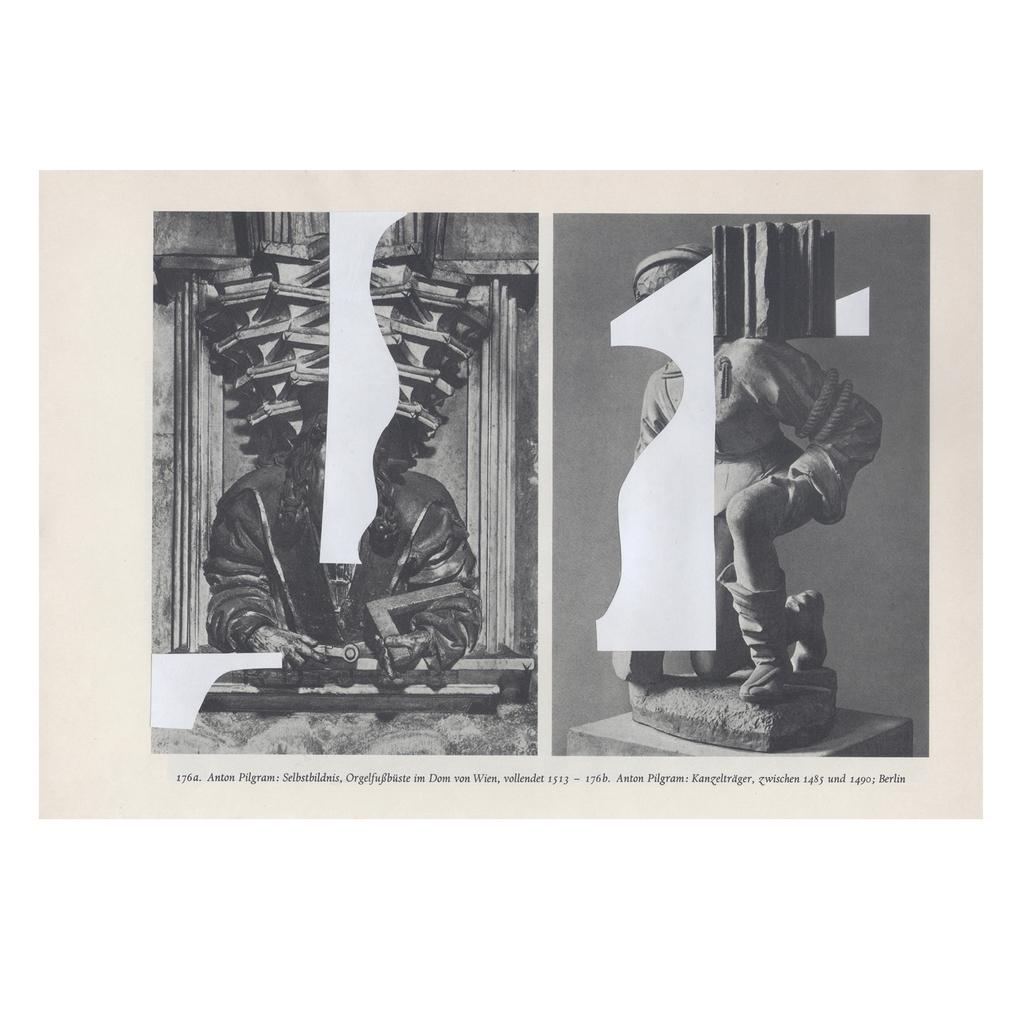What type of image is being described? The image is a poster. What is the main subject of the poster? There is a statue of a person in the poster. Are there any other people depicted in the poster? Yes, there is a person depicted alongside the statue in the poster. What type of liquid is being used for comfort in the poster? There is no liquid or comfort depicted in the poster; it features a statue of a person and another person alongside it. 